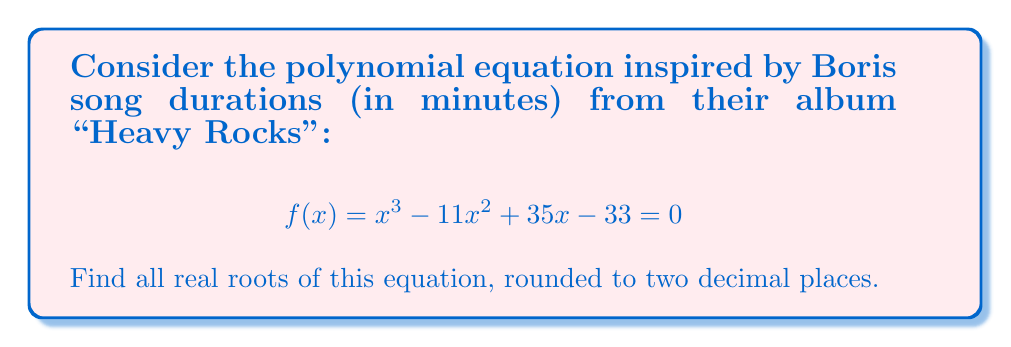Solve this math problem. Let's approach this step-by-step:

1) First, we can use the rational root theorem to find potential rational roots. The potential rational roots are factors of the constant term (±1, ±3, ±11, ±33).

2) Testing these values, we find that 3 is a root of the equation.

3) Since we've found one root, we can factor out $(x-3)$ from the polynomial:

   $$x^3 - 11x^2 + 35x - 33 = (x-3)(x^2 - 8x + 11)$$

4) Now we need to solve the quadratic equation $x^2 - 8x + 11 = 0$

5) We can use the quadratic formula: $x = \frac{-b \pm \sqrt{b^2 - 4ac}}{2a}$

   Where $a=1$, $b=-8$, and $c=11$

6) Substituting these values:

   $$x = \frac{8 \pm \sqrt{64 - 44}}{2} = \frac{8 \pm \sqrt{20}}{2}$$

7) Simplifying:

   $$x = \frac{8 \pm 2\sqrt{5}}{2} = 4 \pm \sqrt{5}$$

8) Therefore, the other two roots are:

   $$x = 4 + \sqrt{5} \approx 6.24$$
   $$x = 4 - \sqrt{5} \approx 1.76$$

9) Rounding to two decimal places, our three roots are 3.00, 6.24, and 1.76.
Answer: The real roots of the equation are approximately 1.76, 3.00, and 6.24. 